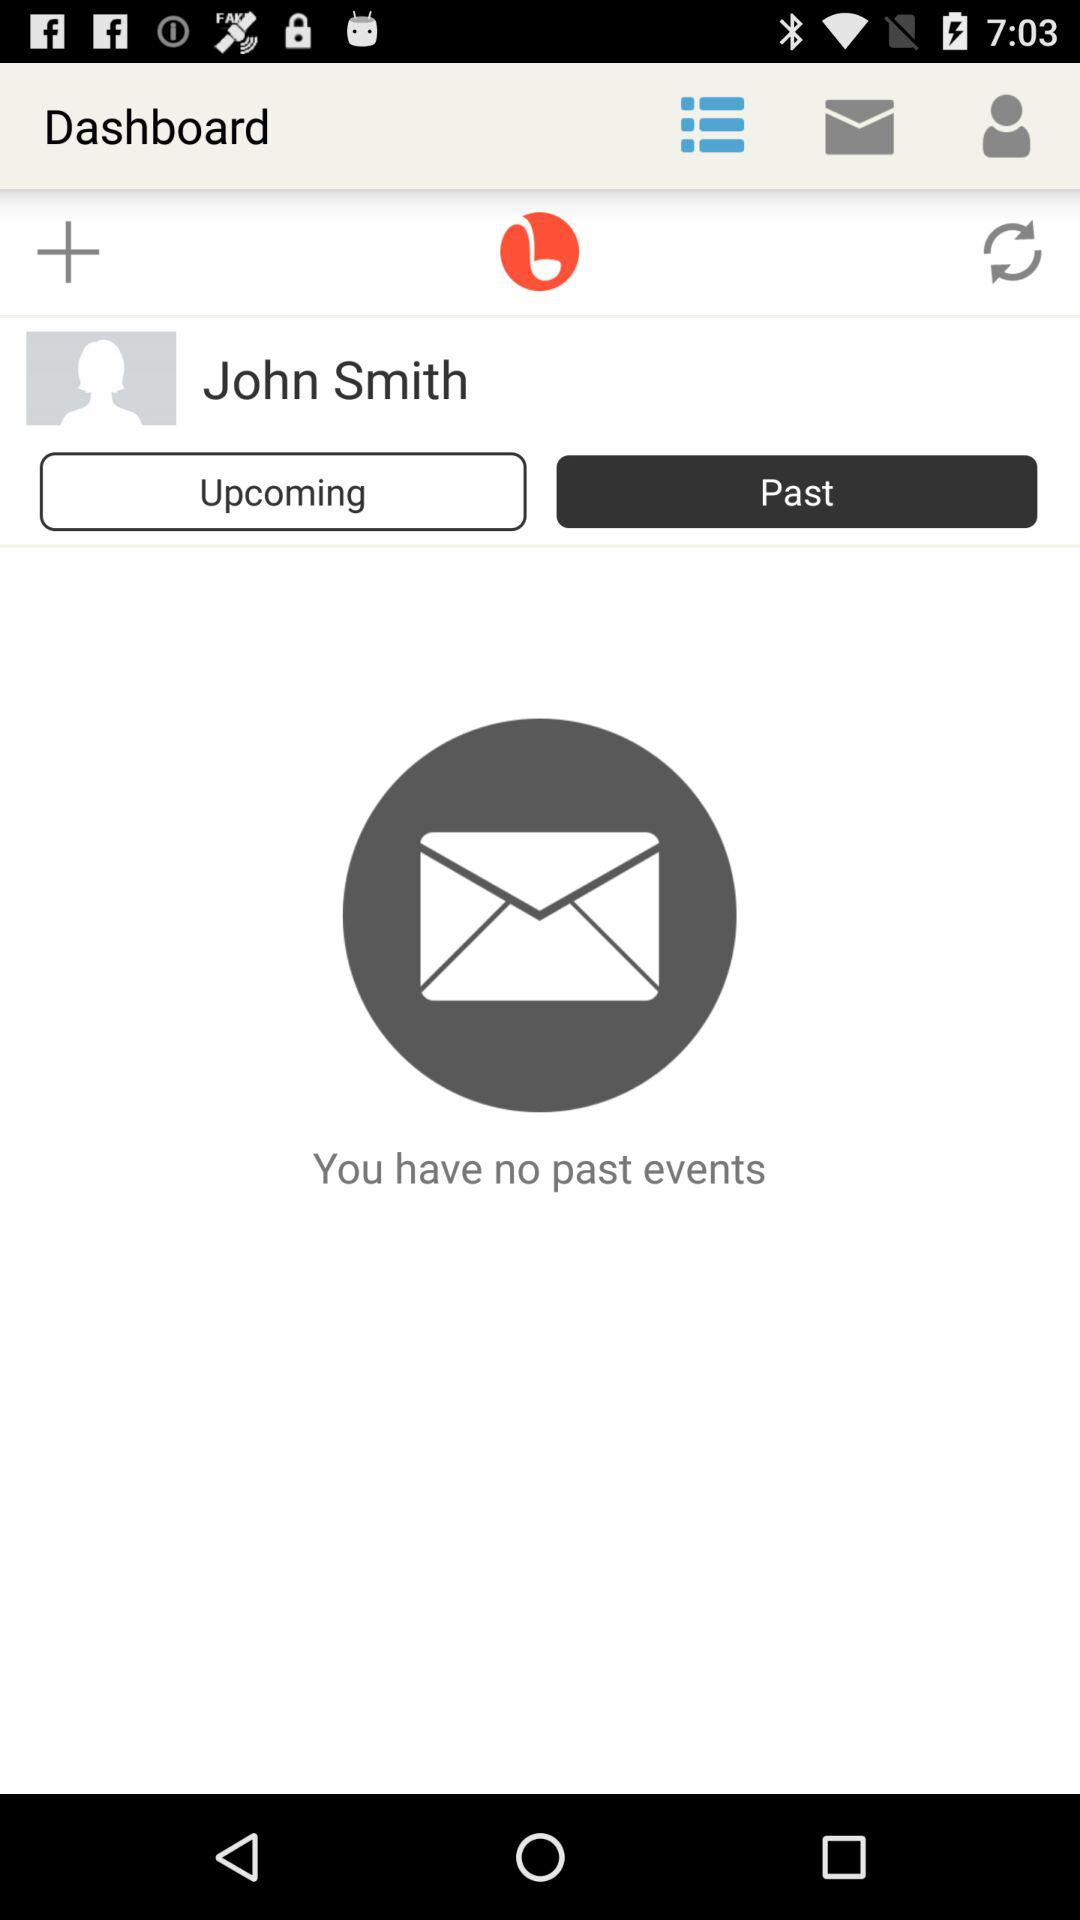What is the application name? The application name is "Dashboard". 